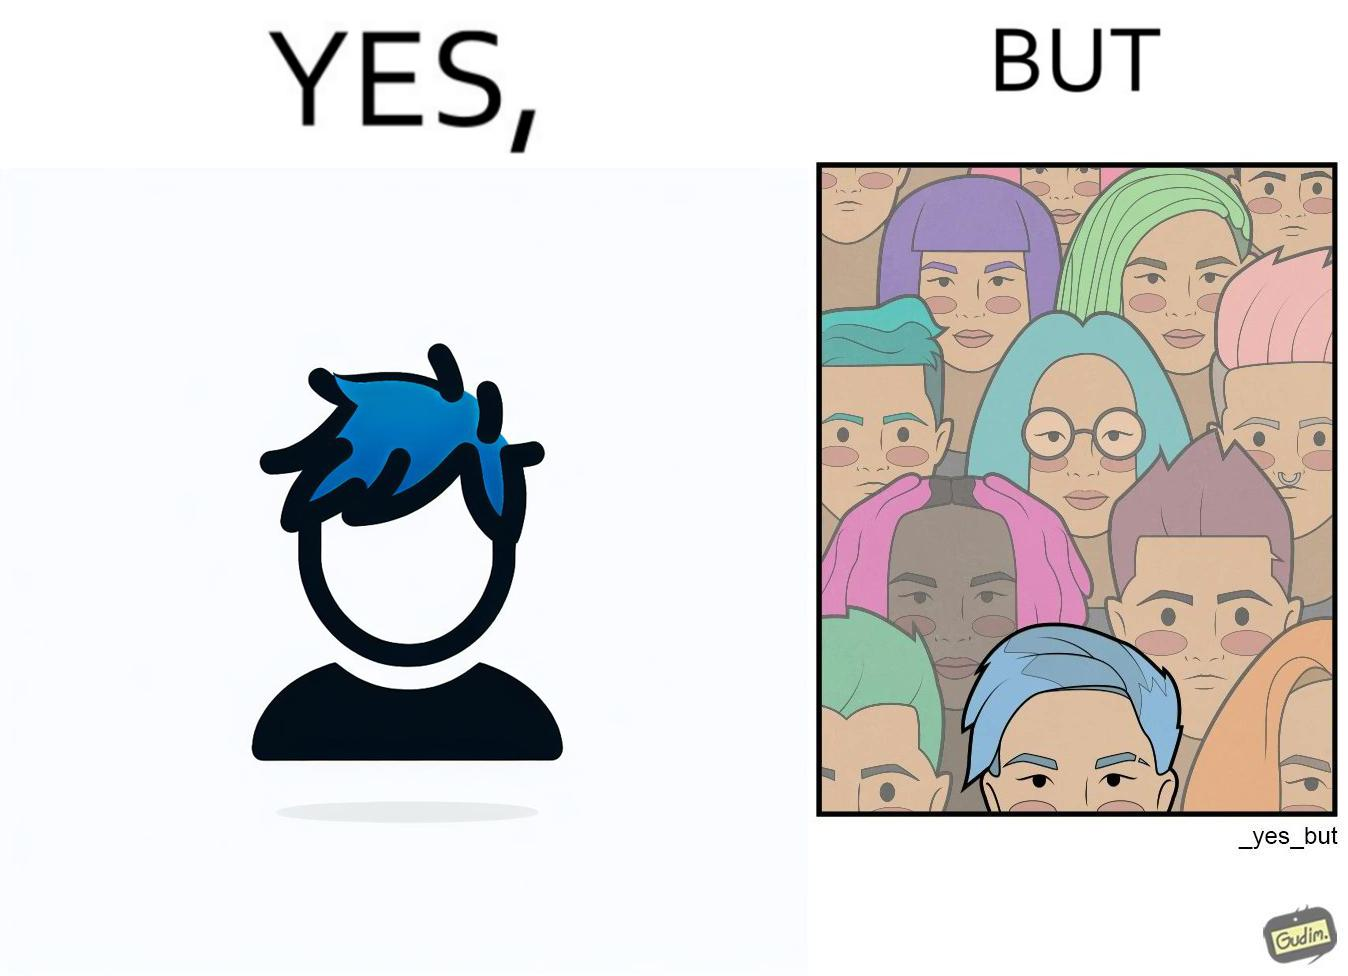Describe what you see in this image. The image is funny, as one person with a hair dyed blue seems to symbolize that the person is going against the grain, however, when we zoom out, the group of people have hair dyed in several, different colors, showing that, dyeing hair is the new normal. 